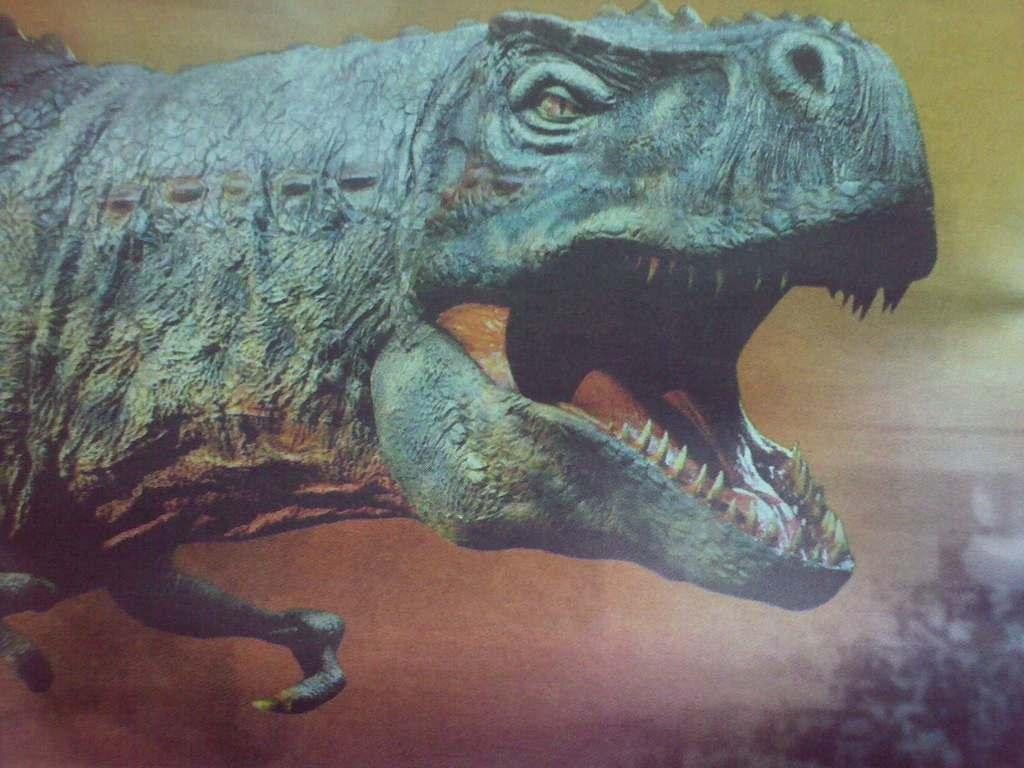What type of animal is depicted in the image? There is an image of a dinosaur in the picture. What degree does the dinosaur have in the image? Dinosaurs do not have degrees, as they are extinct animals and not capable of obtaining academic qualifications. 